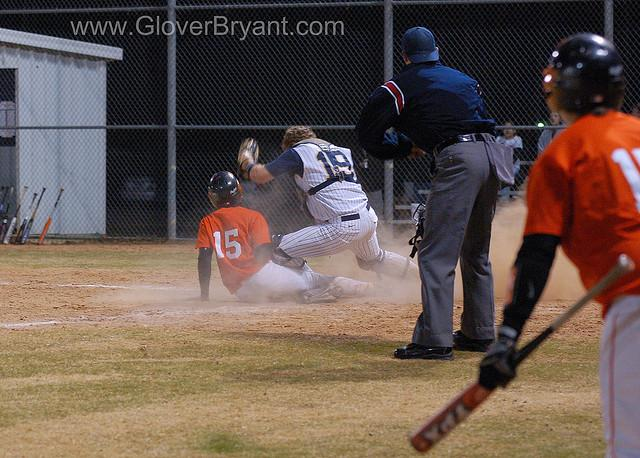What action caused the dust to fly? Please explain your reasoning. sliding. A baseball player is on the ground with another from the opposing team  there as well. 